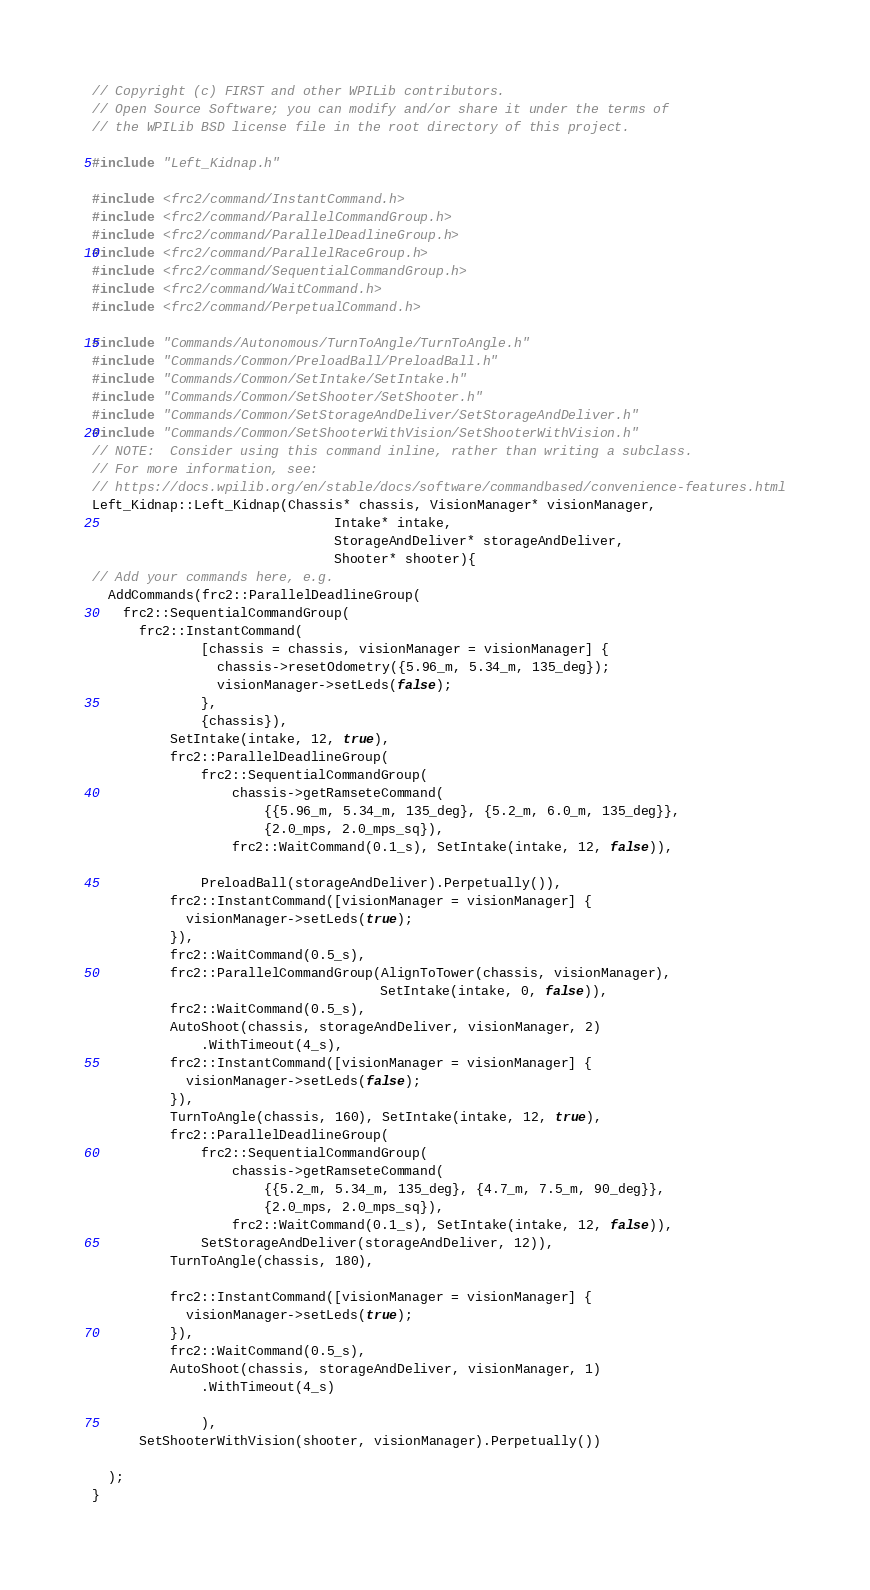<code> <loc_0><loc_0><loc_500><loc_500><_C++_>// Copyright (c) FIRST and other WPILib contributors.
// Open Source Software; you can modify and/or share it under the terms of
// the WPILib BSD license file in the root directory of this project.

#include "Left_Kidnap.h"

#include <frc2/command/InstantCommand.h>
#include <frc2/command/ParallelCommandGroup.h>
#include <frc2/command/ParallelDeadlineGroup.h>
#include <frc2/command/ParallelRaceGroup.h>
#include <frc2/command/SequentialCommandGroup.h>
#include <frc2/command/WaitCommand.h>
#include <frc2/command/PerpetualCommand.h>

#include "Commands/Autonomous/TurnToAngle/TurnToAngle.h"
#include "Commands/Common/PreloadBall/PreloadBall.h"
#include "Commands/Common/SetIntake/SetIntake.h"
#include "Commands/Common/SetShooter/SetShooter.h"
#include "Commands/Common/SetStorageAndDeliver/SetStorageAndDeliver.h"
#include "Commands/Common/SetShooterWithVision/SetShooterWithVision.h"
// NOTE:  Consider using this command inline, rather than writing a subclass.
// For more information, see:
// https://docs.wpilib.org/en/stable/docs/software/commandbased/convenience-features.html
Left_Kidnap::Left_Kidnap(Chassis* chassis, VisionManager* visionManager,
                               Intake* intake,
                               StorageAndDeliver* storageAndDeliver,
                               Shooter* shooter){
// Add your commands here, e.g.
  AddCommands(frc2::ParallelDeadlineGroup(
    frc2::SequentialCommandGroup(
      frc2::InstantCommand(
              [chassis = chassis, visionManager = visionManager] {
                chassis->resetOdometry({5.96_m, 5.34_m, 135_deg});
                visionManager->setLeds(false);
              },
              {chassis}),
          SetIntake(intake, 12, true),
          frc2::ParallelDeadlineGroup(
              frc2::SequentialCommandGroup(
                  chassis->getRamseteCommand(
                      {{5.96_m, 5.34_m, 135_deg}, {5.2_m, 6.0_m, 135_deg}},
                      {2.0_mps, 2.0_mps_sq}),
                  frc2::WaitCommand(0.1_s), SetIntake(intake, 12, false)),

              PreloadBall(storageAndDeliver).Perpetually()),
          frc2::InstantCommand([visionManager = visionManager] {
            visionManager->setLeds(true);
          }),
          frc2::WaitCommand(0.5_s),
          frc2::ParallelCommandGroup(AlignToTower(chassis, visionManager),
                                     SetIntake(intake, 0, false)),
          frc2::WaitCommand(0.5_s),
          AutoShoot(chassis, storageAndDeliver, visionManager, 2)
              .WithTimeout(4_s),
          frc2::InstantCommand([visionManager = visionManager] {
            visionManager->setLeds(false);
          }),
          TurnToAngle(chassis, 160), SetIntake(intake, 12, true),
          frc2::ParallelDeadlineGroup(
              frc2::SequentialCommandGroup(
                  chassis->getRamseteCommand(
                      {{5.2_m, 5.34_m, 135_deg}, {4.7_m, 7.5_m, 90_deg}},
                      {2.0_mps, 2.0_mps_sq}),
                  frc2::WaitCommand(0.1_s), SetIntake(intake, 12, false)),
              SetStorageAndDeliver(storageAndDeliver, 12)),
          TurnToAngle(chassis, 180),

          frc2::InstantCommand([visionManager = visionManager] {
            visionManager->setLeds(true);
          }),
          frc2::WaitCommand(0.5_s),
          AutoShoot(chassis, storageAndDeliver, visionManager, 1)
              .WithTimeout(4_s)

              ),
      SetShooterWithVision(shooter, visionManager).Perpetually())

  );
}
</code> 